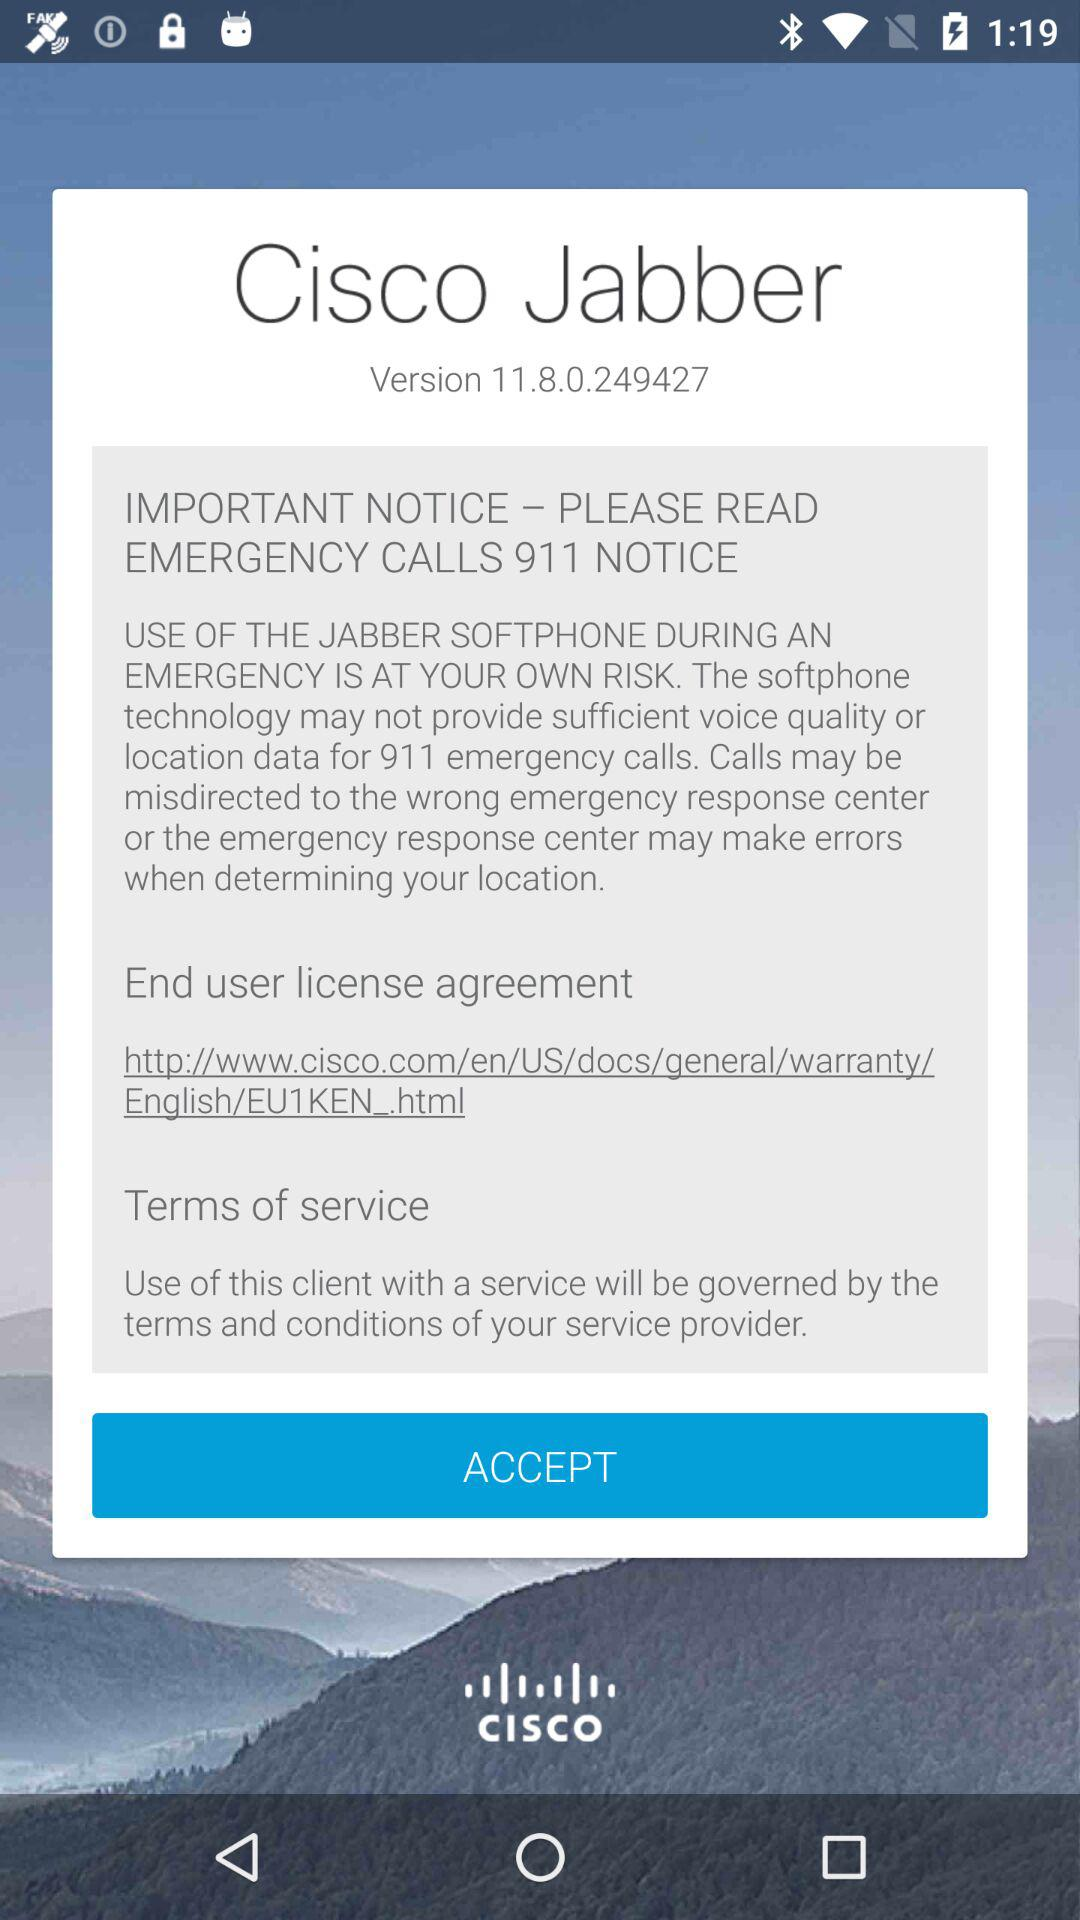What URL can I visit to see the end user license agreement? The URL is http://www.cisco.com/en/US/docs/general/warranty/English/EU1KEN_.html. 